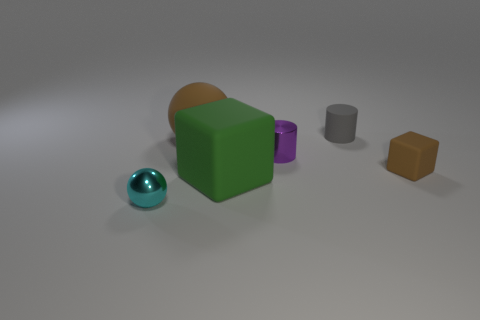What is the texture of the object furthest from the viewer in the image? The object furthest from the viewer seems to have a rough, matte texture and it is a cube with a yellowish-brown color. What can you infer about the lighting in the room? The lighting in the scene gives off a soft ambient quality, with diffuse shadows and subtle highlights, suggesting that the light source is not overly harsh and may be coming from above, somewhat consistent with natural daylight or soft artificial light. 